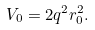Convert formula to latex. <formula><loc_0><loc_0><loc_500><loc_500>V _ { 0 } = 2 q ^ { 2 } r _ { 0 } ^ { 2 } .</formula> 